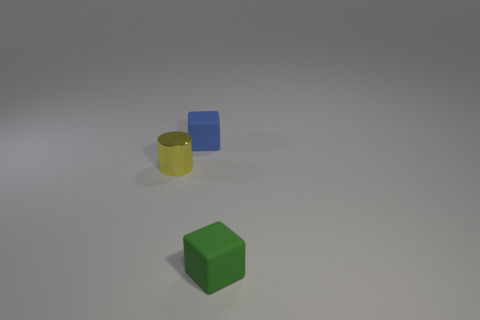Can you describe the arrangement of objects seen in this image? Certainly. In the image, there are three primary objects. A yellow cylinder is placed near the center, slightly left. To its right, there's a smaller blue cube resting on the same surface. And in the foreground, there is a green cube placed closer to the viewer. 